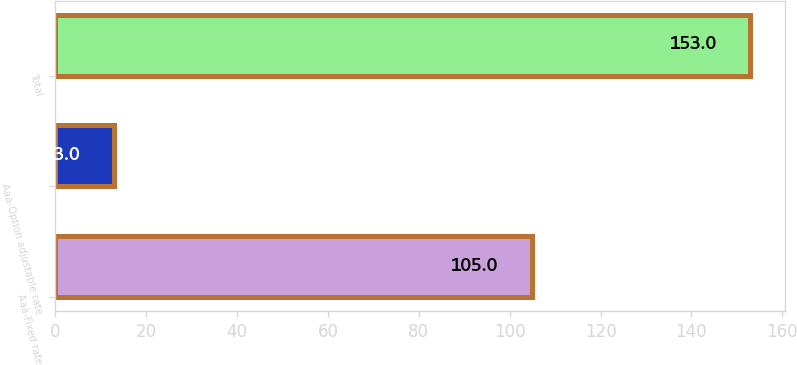<chart> <loc_0><loc_0><loc_500><loc_500><bar_chart><fcel>Aaa-Fixed rate<fcel>Aaa-Option adjustable rate<fcel>Total<nl><fcel>105<fcel>13<fcel>153<nl></chart> 